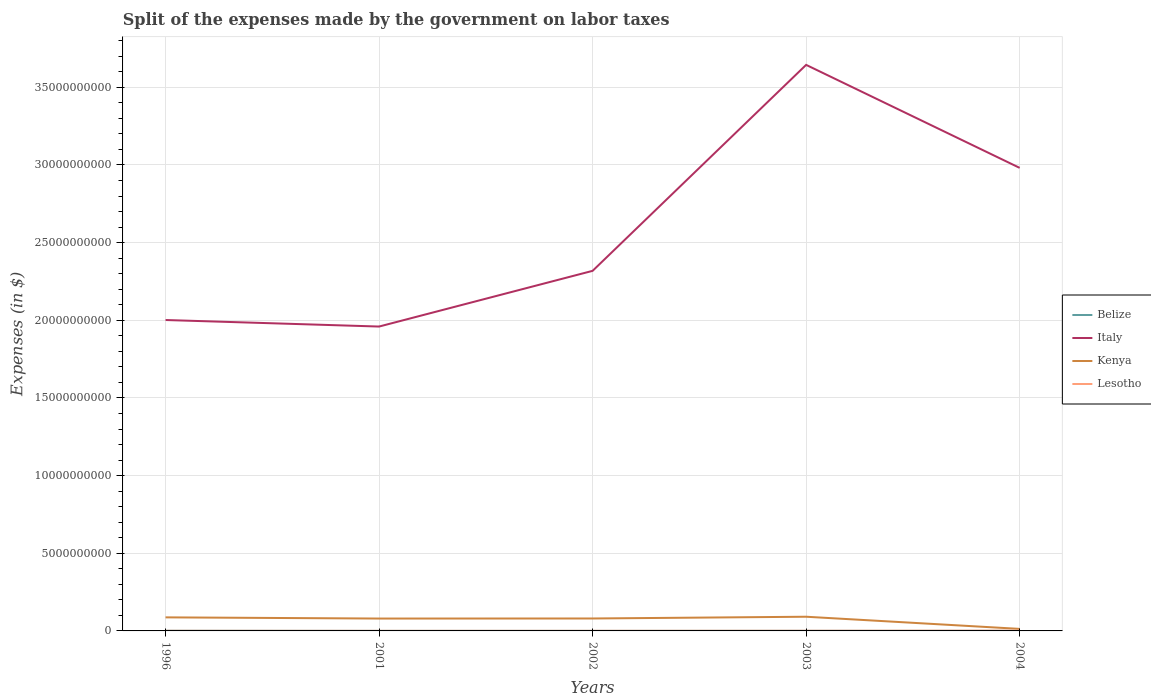How many different coloured lines are there?
Your answer should be very brief. 4. Across all years, what is the maximum expenses made by the government on labor taxes in Belize?
Keep it short and to the point. 2.53e+06. In which year was the expenses made by the government on labor taxes in Belize maximum?
Provide a succinct answer. 2002. What is the total expenses made by the government on labor taxes in Kenya in the graph?
Your answer should be compact. 7.20e+07. What is the difference between the highest and the second highest expenses made by the government on labor taxes in Italy?
Keep it short and to the point. 1.68e+1. Are the values on the major ticks of Y-axis written in scientific E-notation?
Keep it short and to the point. No. Does the graph contain any zero values?
Offer a terse response. No. Where does the legend appear in the graph?
Provide a short and direct response. Center right. How are the legend labels stacked?
Offer a very short reply. Vertical. What is the title of the graph?
Your answer should be compact. Split of the expenses made by the government on labor taxes. Does "Antigua and Barbuda" appear as one of the legend labels in the graph?
Keep it short and to the point. No. What is the label or title of the Y-axis?
Keep it short and to the point. Expenses (in $). What is the Expenses (in $) of Belize in 1996?
Provide a succinct answer. 9.90e+06. What is the Expenses (in $) in Italy in 1996?
Your response must be concise. 2.00e+1. What is the Expenses (in $) in Kenya in 1996?
Your answer should be compact. 8.73e+08. What is the Expenses (in $) of Lesotho in 1996?
Make the answer very short. 7.20e+06. What is the Expenses (in $) in Belize in 2001?
Provide a succinct answer. 2.76e+06. What is the Expenses (in $) in Italy in 2001?
Make the answer very short. 1.96e+1. What is the Expenses (in $) of Kenya in 2001?
Provide a succinct answer. 7.97e+08. What is the Expenses (in $) in Lesotho in 2001?
Offer a terse response. 5.30e+06. What is the Expenses (in $) in Belize in 2002?
Offer a terse response. 2.53e+06. What is the Expenses (in $) in Italy in 2002?
Provide a succinct answer. 2.32e+1. What is the Expenses (in $) of Kenya in 2002?
Your answer should be compact. 8.01e+08. What is the Expenses (in $) in Lesotho in 2002?
Your answer should be compact. 6.40e+06. What is the Expenses (in $) in Belize in 2003?
Make the answer very short. 6.14e+06. What is the Expenses (in $) of Italy in 2003?
Keep it short and to the point. 3.64e+1. What is the Expenses (in $) of Kenya in 2003?
Offer a very short reply. 9.14e+08. What is the Expenses (in $) in Lesotho in 2003?
Your answer should be very brief. 1.05e+07. What is the Expenses (in $) in Belize in 2004?
Offer a terse response. 4.54e+06. What is the Expenses (in $) in Italy in 2004?
Offer a terse response. 2.98e+1. What is the Expenses (in $) of Kenya in 2004?
Your answer should be compact. 1.31e+08. What is the Expenses (in $) in Lesotho in 2004?
Your answer should be compact. 1.78e+07. Across all years, what is the maximum Expenses (in $) of Belize?
Make the answer very short. 9.90e+06. Across all years, what is the maximum Expenses (in $) of Italy?
Your response must be concise. 3.64e+1. Across all years, what is the maximum Expenses (in $) of Kenya?
Offer a very short reply. 9.14e+08. Across all years, what is the maximum Expenses (in $) of Lesotho?
Offer a terse response. 1.78e+07. Across all years, what is the minimum Expenses (in $) in Belize?
Your answer should be compact. 2.53e+06. Across all years, what is the minimum Expenses (in $) in Italy?
Give a very brief answer. 1.96e+1. Across all years, what is the minimum Expenses (in $) in Kenya?
Provide a succinct answer. 1.31e+08. Across all years, what is the minimum Expenses (in $) in Lesotho?
Provide a succinct answer. 5.30e+06. What is the total Expenses (in $) in Belize in the graph?
Keep it short and to the point. 2.59e+07. What is the total Expenses (in $) in Italy in the graph?
Ensure brevity in your answer.  1.29e+11. What is the total Expenses (in $) of Kenya in the graph?
Keep it short and to the point. 3.52e+09. What is the total Expenses (in $) in Lesotho in the graph?
Provide a succinct answer. 4.72e+07. What is the difference between the Expenses (in $) of Belize in 1996 and that in 2001?
Give a very brief answer. 7.13e+06. What is the difference between the Expenses (in $) of Italy in 1996 and that in 2001?
Provide a succinct answer. 4.20e+08. What is the difference between the Expenses (in $) of Kenya in 1996 and that in 2001?
Make the answer very short. 7.65e+07. What is the difference between the Expenses (in $) of Lesotho in 1996 and that in 2001?
Keep it short and to the point. 1.90e+06. What is the difference between the Expenses (in $) in Belize in 1996 and that in 2002?
Your response must be concise. 7.37e+06. What is the difference between the Expenses (in $) of Italy in 1996 and that in 2002?
Offer a very short reply. -3.17e+09. What is the difference between the Expenses (in $) in Kenya in 1996 and that in 2002?
Make the answer very short. 7.20e+07. What is the difference between the Expenses (in $) of Belize in 1996 and that in 2003?
Ensure brevity in your answer.  3.76e+06. What is the difference between the Expenses (in $) of Italy in 1996 and that in 2003?
Provide a succinct answer. -1.64e+1. What is the difference between the Expenses (in $) in Kenya in 1996 and that in 2003?
Your answer should be very brief. -4.07e+07. What is the difference between the Expenses (in $) of Lesotho in 1996 and that in 2003?
Ensure brevity in your answer.  -3.28e+06. What is the difference between the Expenses (in $) in Belize in 1996 and that in 2004?
Give a very brief answer. 5.36e+06. What is the difference between the Expenses (in $) of Italy in 1996 and that in 2004?
Keep it short and to the point. -9.80e+09. What is the difference between the Expenses (in $) in Kenya in 1996 and that in 2004?
Give a very brief answer. 7.42e+08. What is the difference between the Expenses (in $) in Lesotho in 1996 and that in 2004?
Make the answer very short. -1.06e+07. What is the difference between the Expenses (in $) of Belize in 2001 and that in 2002?
Offer a terse response. 2.33e+05. What is the difference between the Expenses (in $) in Italy in 2001 and that in 2002?
Provide a short and direct response. -3.59e+09. What is the difference between the Expenses (in $) in Kenya in 2001 and that in 2002?
Your answer should be compact. -4.44e+06. What is the difference between the Expenses (in $) in Lesotho in 2001 and that in 2002?
Give a very brief answer. -1.10e+06. What is the difference between the Expenses (in $) of Belize in 2001 and that in 2003?
Keep it short and to the point. -3.38e+06. What is the difference between the Expenses (in $) in Italy in 2001 and that in 2003?
Your answer should be very brief. -1.68e+1. What is the difference between the Expenses (in $) of Kenya in 2001 and that in 2003?
Provide a short and direct response. -1.17e+08. What is the difference between the Expenses (in $) in Lesotho in 2001 and that in 2003?
Your response must be concise. -5.18e+06. What is the difference between the Expenses (in $) in Belize in 2001 and that in 2004?
Ensure brevity in your answer.  -1.77e+06. What is the difference between the Expenses (in $) of Italy in 2001 and that in 2004?
Give a very brief answer. -1.02e+1. What is the difference between the Expenses (in $) in Kenya in 2001 and that in 2004?
Offer a terse response. 6.66e+08. What is the difference between the Expenses (in $) of Lesotho in 2001 and that in 2004?
Your answer should be compact. -1.25e+07. What is the difference between the Expenses (in $) of Belize in 2002 and that in 2003?
Offer a terse response. -3.61e+06. What is the difference between the Expenses (in $) in Italy in 2002 and that in 2003?
Your response must be concise. -1.33e+1. What is the difference between the Expenses (in $) in Kenya in 2002 and that in 2003?
Provide a short and direct response. -1.13e+08. What is the difference between the Expenses (in $) in Lesotho in 2002 and that in 2003?
Your answer should be compact. -4.08e+06. What is the difference between the Expenses (in $) of Belize in 2002 and that in 2004?
Your answer should be very brief. -2.00e+06. What is the difference between the Expenses (in $) in Italy in 2002 and that in 2004?
Offer a terse response. -6.63e+09. What is the difference between the Expenses (in $) in Kenya in 2002 and that in 2004?
Make the answer very short. 6.70e+08. What is the difference between the Expenses (in $) of Lesotho in 2002 and that in 2004?
Your answer should be compact. -1.14e+07. What is the difference between the Expenses (in $) in Belize in 2003 and that in 2004?
Make the answer very short. 1.61e+06. What is the difference between the Expenses (in $) of Italy in 2003 and that in 2004?
Give a very brief answer. 6.63e+09. What is the difference between the Expenses (in $) of Kenya in 2003 and that in 2004?
Ensure brevity in your answer.  7.83e+08. What is the difference between the Expenses (in $) in Lesotho in 2003 and that in 2004?
Offer a very short reply. -7.32e+06. What is the difference between the Expenses (in $) in Belize in 1996 and the Expenses (in $) in Italy in 2001?
Your answer should be compact. -1.96e+1. What is the difference between the Expenses (in $) in Belize in 1996 and the Expenses (in $) in Kenya in 2001?
Ensure brevity in your answer.  -7.87e+08. What is the difference between the Expenses (in $) in Belize in 1996 and the Expenses (in $) in Lesotho in 2001?
Offer a very short reply. 4.60e+06. What is the difference between the Expenses (in $) in Italy in 1996 and the Expenses (in $) in Kenya in 2001?
Provide a short and direct response. 1.92e+1. What is the difference between the Expenses (in $) of Italy in 1996 and the Expenses (in $) of Lesotho in 2001?
Offer a terse response. 2.00e+1. What is the difference between the Expenses (in $) in Kenya in 1996 and the Expenses (in $) in Lesotho in 2001?
Your answer should be very brief. 8.68e+08. What is the difference between the Expenses (in $) of Belize in 1996 and the Expenses (in $) of Italy in 2002?
Offer a very short reply. -2.32e+1. What is the difference between the Expenses (in $) in Belize in 1996 and the Expenses (in $) in Kenya in 2002?
Your answer should be compact. -7.91e+08. What is the difference between the Expenses (in $) of Belize in 1996 and the Expenses (in $) of Lesotho in 2002?
Your answer should be very brief. 3.50e+06. What is the difference between the Expenses (in $) of Italy in 1996 and the Expenses (in $) of Kenya in 2002?
Your response must be concise. 1.92e+1. What is the difference between the Expenses (in $) of Italy in 1996 and the Expenses (in $) of Lesotho in 2002?
Offer a terse response. 2.00e+1. What is the difference between the Expenses (in $) in Kenya in 1996 and the Expenses (in $) in Lesotho in 2002?
Offer a very short reply. 8.67e+08. What is the difference between the Expenses (in $) in Belize in 1996 and the Expenses (in $) in Italy in 2003?
Provide a succinct answer. -3.64e+1. What is the difference between the Expenses (in $) of Belize in 1996 and the Expenses (in $) of Kenya in 2003?
Offer a terse response. -9.04e+08. What is the difference between the Expenses (in $) of Belize in 1996 and the Expenses (in $) of Lesotho in 2003?
Your answer should be very brief. -5.78e+05. What is the difference between the Expenses (in $) in Italy in 1996 and the Expenses (in $) in Kenya in 2003?
Offer a terse response. 1.91e+1. What is the difference between the Expenses (in $) of Italy in 1996 and the Expenses (in $) of Lesotho in 2003?
Keep it short and to the point. 2.00e+1. What is the difference between the Expenses (in $) in Kenya in 1996 and the Expenses (in $) in Lesotho in 2003?
Provide a succinct answer. 8.63e+08. What is the difference between the Expenses (in $) in Belize in 1996 and the Expenses (in $) in Italy in 2004?
Offer a very short reply. -2.98e+1. What is the difference between the Expenses (in $) of Belize in 1996 and the Expenses (in $) of Kenya in 2004?
Offer a terse response. -1.21e+08. What is the difference between the Expenses (in $) of Belize in 1996 and the Expenses (in $) of Lesotho in 2004?
Your answer should be very brief. -7.90e+06. What is the difference between the Expenses (in $) of Italy in 1996 and the Expenses (in $) of Kenya in 2004?
Offer a very short reply. 1.99e+1. What is the difference between the Expenses (in $) of Italy in 1996 and the Expenses (in $) of Lesotho in 2004?
Provide a succinct answer. 2.00e+1. What is the difference between the Expenses (in $) in Kenya in 1996 and the Expenses (in $) in Lesotho in 2004?
Offer a very short reply. 8.55e+08. What is the difference between the Expenses (in $) of Belize in 2001 and the Expenses (in $) of Italy in 2002?
Your answer should be compact. -2.32e+1. What is the difference between the Expenses (in $) of Belize in 2001 and the Expenses (in $) of Kenya in 2002?
Provide a short and direct response. -7.98e+08. What is the difference between the Expenses (in $) in Belize in 2001 and the Expenses (in $) in Lesotho in 2002?
Provide a succinct answer. -3.64e+06. What is the difference between the Expenses (in $) of Italy in 2001 and the Expenses (in $) of Kenya in 2002?
Provide a succinct answer. 1.88e+1. What is the difference between the Expenses (in $) in Italy in 2001 and the Expenses (in $) in Lesotho in 2002?
Your answer should be compact. 1.96e+1. What is the difference between the Expenses (in $) in Kenya in 2001 and the Expenses (in $) in Lesotho in 2002?
Provide a succinct answer. 7.90e+08. What is the difference between the Expenses (in $) of Belize in 2001 and the Expenses (in $) of Italy in 2003?
Make the answer very short. -3.64e+1. What is the difference between the Expenses (in $) of Belize in 2001 and the Expenses (in $) of Kenya in 2003?
Provide a succinct answer. -9.11e+08. What is the difference between the Expenses (in $) in Belize in 2001 and the Expenses (in $) in Lesotho in 2003?
Your answer should be very brief. -7.71e+06. What is the difference between the Expenses (in $) of Italy in 2001 and the Expenses (in $) of Kenya in 2003?
Ensure brevity in your answer.  1.87e+1. What is the difference between the Expenses (in $) in Italy in 2001 and the Expenses (in $) in Lesotho in 2003?
Offer a very short reply. 1.96e+1. What is the difference between the Expenses (in $) in Kenya in 2001 and the Expenses (in $) in Lesotho in 2003?
Your answer should be very brief. 7.86e+08. What is the difference between the Expenses (in $) of Belize in 2001 and the Expenses (in $) of Italy in 2004?
Give a very brief answer. -2.98e+1. What is the difference between the Expenses (in $) of Belize in 2001 and the Expenses (in $) of Kenya in 2004?
Keep it short and to the point. -1.28e+08. What is the difference between the Expenses (in $) of Belize in 2001 and the Expenses (in $) of Lesotho in 2004?
Keep it short and to the point. -1.50e+07. What is the difference between the Expenses (in $) in Italy in 2001 and the Expenses (in $) in Kenya in 2004?
Your response must be concise. 1.95e+1. What is the difference between the Expenses (in $) of Italy in 2001 and the Expenses (in $) of Lesotho in 2004?
Offer a terse response. 1.96e+1. What is the difference between the Expenses (in $) in Kenya in 2001 and the Expenses (in $) in Lesotho in 2004?
Ensure brevity in your answer.  7.79e+08. What is the difference between the Expenses (in $) of Belize in 2002 and the Expenses (in $) of Italy in 2003?
Provide a short and direct response. -3.64e+1. What is the difference between the Expenses (in $) in Belize in 2002 and the Expenses (in $) in Kenya in 2003?
Make the answer very short. -9.11e+08. What is the difference between the Expenses (in $) of Belize in 2002 and the Expenses (in $) of Lesotho in 2003?
Provide a short and direct response. -7.94e+06. What is the difference between the Expenses (in $) in Italy in 2002 and the Expenses (in $) in Kenya in 2003?
Your answer should be compact. 2.23e+1. What is the difference between the Expenses (in $) of Italy in 2002 and the Expenses (in $) of Lesotho in 2003?
Keep it short and to the point. 2.32e+1. What is the difference between the Expenses (in $) of Kenya in 2002 and the Expenses (in $) of Lesotho in 2003?
Your response must be concise. 7.90e+08. What is the difference between the Expenses (in $) in Belize in 2002 and the Expenses (in $) in Italy in 2004?
Your response must be concise. -2.98e+1. What is the difference between the Expenses (in $) of Belize in 2002 and the Expenses (in $) of Kenya in 2004?
Ensure brevity in your answer.  -1.28e+08. What is the difference between the Expenses (in $) in Belize in 2002 and the Expenses (in $) in Lesotho in 2004?
Your answer should be compact. -1.53e+07. What is the difference between the Expenses (in $) in Italy in 2002 and the Expenses (in $) in Kenya in 2004?
Keep it short and to the point. 2.31e+1. What is the difference between the Expenses (in $) in Italy in 2002 and the Expenses (in $) in Lesotho in 2004?
Give a very brief answer. 2.32e+1. What is the difference between the Expenses (in $) in Kenya in 2002 and the Expenses (in $) in Lesotho in 2004?
Give a very brief answer. 7.83e+08. What is the difference between the Expenses (in $) of Belize in 2003 and the Expenses (in $) of Italy in 2004?
Provide a short and direct response. -2.98e+1. What is the difference between the Expenses (in $) in Belize in 2003 and the Expenses (in $) in Kenya in 2004?
Your answer should be compact. -1.25e+08. What is the difference between the Expenses (in $) of Belize in 2003 and the Expenses (in $) of Lesotho in 2004?
Your response must be concise. -1.17e+07. What is the difference between the Expenses (in $) in Italy in 2003 and the Expenses (in $) in Kenya in 2004?
Ensure brevity in your answer.  3.63e+1. What is the difference between the Expenses (in $) in Italy in 2003 and the Expenses (in $) in Lesotho in 2004?
Make the answer very short. 3.64e+1. What is the difference between the Expenses (in $) of Kenya in 2003 and the Expenses (in $) of Lesotho in 2004?
Your answer should be compact. 8.96e+08. What is the average Expenses (in $) in Belize per year?
Give a very brief answer. 5.17e+06. What is the average Expenses (in $) in Italy per year?
Your answer should be compact. 2.58e+1. What is the average Expenses (in $) in Kenya per year?
Ensure brevity in your answer.  7.03e+08. What is the average Expenses (in $) of Lesotho per year?
Ensure brevity in your answer.  9.43e+06. In the year 1996, what is the difference between the Expenses (in $) in Belize and Expenses (in $) in Italy?
Keep it short and to the point. -2.00e+1. In the year 1996, what is the difference between the Expenses (in $) of Belize and Expenses (in $) of Kenya?
Provide a short and direct response. -8.63e+08. In the year 1996, what is the difference between the Expenses (in $) in Belize and Expenses (in $) in Lesotho?
Offer a terse response. 2.70e+06. In the year 1996, what is the difference between the Expenses (in $) in Italy and Expenses (in $) in Kenya?
Provide a succinct answer. 1.91e+1. In the year 1996, what is the difference between the Expenses (in $) in Italy and Expenses (in $) in Lesotho?
Keep it short and to the point. 2.00e+1. In the year 1996, what is the difference between the Expenses (in $) of Kenya and Expenses (in $) of Lesotho?
Your answer should be compact. 8.66e+08. In the year 2001, what is the difference between the Expenses (in $) in Belize and Expenses (in $) in Italy?
Make the answer very short. -1.96e+1. In the year 2001, what is the difference between the Expenses (in $) in Belize and Expenses (in $) in Kenya?
Keep it short and to the point. -7.94e+08. In the year 2001, what is the difference between the Expenses (in $) of Belize and Expenses (in $) of Lesotho?
Your response must be concise. -2.54e+06. In the year 2001, what is the difference between the Expenses (in $) of Italy and Expenses (in $) of Kenya?
Keep it short and to the point. 1.88e+1. In the year 2001, what is the difference between the Expenses (in $) in Italy and Expenses (in $) in Lesotho?
Offer a terse response. 1.96e+1. In the year 2001, what is the difference between the Expenses (in $) of Kenya and Expenses (in $) of Lesotho?
Offer a very short reply. 7.91e+08. In the year 2002, what is the difference between the Expenses (in $) in Belize and Expenses (in $) in Italy?
Offer a very short reply. -2.32e+1. In the year 2002, what is the difference between the Expenses (in $) of Belize and Expenses (in $) of Kenya?
Your answer should be compact. -7.98e+08. In the year 2002, what is the difference between the Expenses (in $) of Belize and Expenses (in $) of Lesotho?
Provide a succinct answer. -3.87e+06. In the year 2002, what is the difference between the Expenses (in $) of Italy and Expenses (in $) of Kenya?
Make the answer very short. 2.24e+1. In the year 2002, what is the difference between the Expenses (in $) in Italy and Expenses (in $) in Lesotho?
Your answer should be compact. 2.32e+1. In the year 2002, what is the difference between the Expenses (in $) in Kenya and Expenses (in $) in Lesotho?
Your answer should be very brief. 7.95e+08. In the year 2003, what is the difference between the Expenses (in $) in Belize and Expenses (in $) in Italy?
Provide a succinct answer. -3.64e+1. In the year 2003, what is the difference between the Expenses (in $) of Belize and Expenses (in $) of Kenya?
Your answer should be very brief. -9.08e+08. In the year 2003, what is the difference between the Expenses (in $) in Belize and Expenses (in $) in Lesotho?
Give a very brief answer. -4.33e+06. In the year 2003, what is the difference between the Expenses (in $) of Italy and Expenses (in $) of Kenya?
Provide a short and direct response. 3.55e+1. In the year 2003, what is the difference between the Expenses (in $) in Italy and Expenses (in $) in Lesotho?
Give a very brief answer. 3.64e+1. In the year 2003, what is the difference between the Expenses (in $) of Kenya and Expenses (in $) of Lesotho?
Give a very brief answer. 9.03e+08. In the year 2004, what is the difference between the Expenses (in $) in Belize and Expenses (in $) in Italy?
Keep it short and to the point. -2.98e+1. In the year 2004, what is the difference between the Expenses (in $) in Belize and Expenses (in $) in Kenya?
Provide a succinct answer. -1.26e+08. In the year 2004, what is the difference between the Expenses (in $) in Belize and Expenses (in $) in Lesotho?
Ensure brevity in your answer.  -1.33e+07. In the year 2004, what is the difference between the Expenses (in $) of Italy and Expenses (in $) of Kenya?
Your answer should be very brief. 2.97e+1. In the year 2004, what is the difference between the Expenses (in $) of Italy and Expenses (in $) of Lesotho?
Give a very brief answer. 2.98e+1. In the year 2004, what is the difference between the Expenses (in $) of Kenya and Expenses (in $) of Lesotho?
Your answer should be compact. 1.13e+08. What is the ratio of the Expenses (in $) of Belize in 1996 to that in 2001?
Give a very brief answer. 3.58. What is the ratio of the Expenses (in $) in Italy in 1996 to that in 2001?
Your answer should be compact. 1.02. What is the ratio of the Expenses (in $) of Kenya in 1996 to that in 2001?
Your response must be concise. 1.1. What is the ratio of the Expenses (in $) of Lesotho in 1996 to that in 2001?
Keep it short and to the point. 1.36. What is the ratio of the Expenses (in $) in Belize in 1996 to that in 2002?
Provide a succinct answer. 3.91. What is the ratio of the Expenses (in $) in Italy in 1996 to that in 2002?
Give a very brief answer. 0.86. What is the ratio of the Expenses (in $) of Kenya in 1996 to that in 2002?
Your answer should be compact. 1.09. What is the ratio of the Expenses (in $) of Lesotho in 1996 to that in 2002?
Offer a terse response. 1.12. What is the ratio of the Expenses (in $) in Belize in 1996 to that in 2003?
Provide a short and direct response. 1.61. What is the ratio of the Expenses (in $) of Italy in 1996 to that in 2003?
Make the answer very short. 0.55. What is the ratio of the Expenses (in $) in Kenya in 1996 to that in 2003?
Your answer should be compact. 0.96. What is the ratio of the Expenses (in $) in Lesotho in 1996 to that in 2003?
Provide a short and direct response. 0.69. What is the ratio of the Expenses (in $) in Belize in 1996 to that in 2004?
Provide a succinct answer. 2.18. What is the ratio of the Expenses (in $) in Italy in 1996 to that in 2004?
Give a very brief answer. 0.67. What is the ratio of the Expenses (in $) in Kenya in 1996 to that in 2004?
Make the answer very short. 6.66. What is the ratio of the Expenses (in $) of Lesotho in 1996 to that in 2004?
Your response must be concise. 0.4. What is the ratio of the Expenses (in $) in Belize in 2001 to that in 2002?
Offer a very short reply. 1.09. What is the ratio of the Expenses (in $) in Italy in 2001 to that in 2002?
Your answer should be compact. 0.85. What is the ratio of the Expenses (in $) of Kenya in 2001 to that in 2002?
Your answer should be compact. 0.99. What is the ratio of the Expenses (in $) in Lesotho in 2001 to that in 2002?
Offer a terse response. 0.83. What is the ratio of the Expenses (in $) of Belize in 2001 to that in 2003?
Keep it short and to the point. 0.45. What is the ratio of the Expenses (in $) of Italy in 2001 to that in 2003?
Your response must be concise. 0.54. What is the ratio of the Expenses (in $) in Kenya in 2001 to that in 2003?
Your response must be concise. 0.87. What is the ratio of the Expenses (in $) in Lesotho in 2001 to that in 2003?
Provide a short and direct response. 0.51. What is the ratio of the Expenses (in $) of Belize in 2001 to that in 2004?
Your answer should be very brief. 0.61. What is the ratio of the Expenses (in $) of Italy in 2001 to that in 2004?
Keep it short and to the point. 0.66. What is the ratio of the Expenses (in $) in Kenya in 2001 to that in 2004?
Offer a very short reply. 6.08. What is the ratio of the Expenses (in $) of Lesotho in 2001 to that in 2004?
Your answer should be compact. 0.3. What is the ratio of the Expenses (in $) in Belize in 2002 to that in 2003?
Your response must be concise. 0.41. What is the ratio of the Expenses (in $) of Italy in 2002 to that in 2003?
Your answer should be very brief. 0.64. What is the ratio of the Expenses (in $) in Kenya in 2002 to that in 2003?
Provide a succinct answer. 0.88. What is the ratio of the Expenses (in $) of Lesotho in 2002 to that in 2003?
Provide a succinct answer. 0.61. What is the ratio of the Expenses (in $) in Belize in 2002 to that in 2004?
Your response must be concise. 0.56. What is the ratio of the Expenses (in $) of Italy in 2002 to that in 2004?
Your answer should be compact. 0.78. What is the ratio of the Expenses (in $) of Kenya in 2002 to that in 2004?
Offer a very short reply. 6.11. What is the ratio of the Expenses (in $) of Lesotho in 2002 to that in 2004?
Make the answer very short. 0.36. What is the ratio of the Expenses (in $) in Belize in 2003 to that in 2004?
Provide a succinct answer. 1.35. What is the ratio of the Expenses (in $) of Italy in 2003 to that in 2004?
Your response must be concise. 1.22. What is the ratio of the Expenses (in $) in Kenya in 2003 to that in 2004?
Give a very brief answer. 6.97. What is the ratio of the Expenses (in $) of Lesotho in 2003 to that in 2004?
Give a very brief answer. 0.59. What is the difference between the highest and the second highest Expenses (in $) in Belize?
Provide a succinct answer. 3.76e+06. What is the difference between the highest and the second highest Expenses (in $) in Italy?
Keep it short and to the point. 6.63e+09. What is the difference between the highest and the second highest Expenses (in $) of Kenya?
Provide a short and direct response. 4.07e+07. What is the difference between the highest and the second highest Expenses (in $) of Lesotho?
Provide a succinct answer. 7.32e+06. What is the difference between the highest and the lowest Expenses (in $) in Belize?
Your answer should be very brief. 7.37e+06. What is the difference between the highest and the lowest Expenses (in $) in Italy?
Your answer should be compact. 1.68e+1. What is the difference between the highest and the lowest Expenses (in $) of Kenya?
Keep it short and to the point. 7.83e+08. What is the difference between the highest and the lowest Expenses (in $) in Lesotho?
Your answer should be very brief. 1.25e+07. 